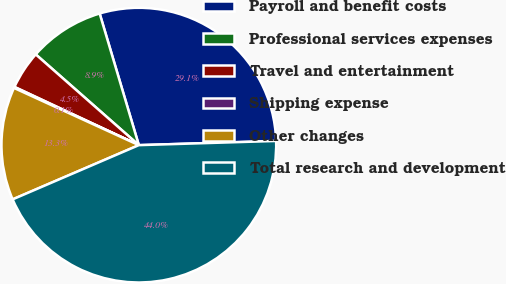Convert chart. <chart><loc_0><loc_0><loc_500><loc_500><pie_chart><fcel>Payroll and benefit costs<fcel>Professional services expenses<fcel>Travel and entertainment<fcel>Shipping expense<fcel>Other changes<fcel>Total research and development<nl><fcel>29.12%<fcel>8.91%<fcel>4.52%<fcel>0.13%<fcel>13.3%<fcel>44.03%<nl></chart> 